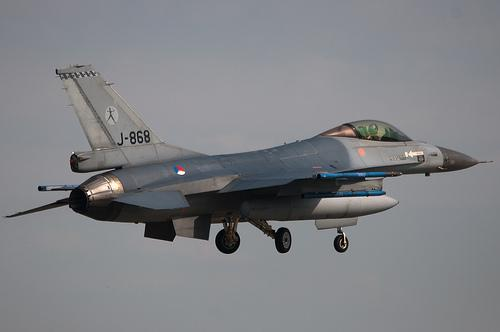Analyze the interaction between the main subject and the background. The main subject, the plane, is actively flying through the sky, interacting and contrasting with the background composed of multiple instances of the sky. Mention the main subject of this image and describe its position. The main subject is a plane flying in the sky. It occupies a large portion of the image with various parts like the nose, wheels, and tail distributed across the space. Count the total number of objects in the image and specify their types. There are 27 objects in the image, including sky, plane, plane parts (nose, wheels, tail, etc.), logo, text, and pilot. What can you tell about the color of the plane and the presence of any logo or text on it? The plane is gray and has a logo, which is red, white, and blue. There are also letters and numbers painted in black on the plane. Identify the quality of the image based on the given information. It is difficult to determine the quality of the image based only on the given information, as it only provides coordinates and dimensions of various objects. Evaluate the image sentiment based on the contents. The image sentiment can be perceived as positive and dynamic, as it showcases a plane soaring in the sky, indicating progress, movement, and possibly adventure. 